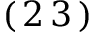<formula> <loc_0><loc_0><loc_500><loc_500>( \, 2 \, 3 \, )</formula> 